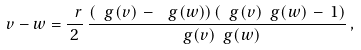<formula> <loc_0><loc_0><loc_500><loc_500>v - w = \frac { \ r } { 2 } \, \frac { ( \ g ( v ) \, - \, \ g ( w ) ) \, ( \ g ( v ) \ g ( w ) \, - \, 1 ) } { \ g ( v ) \ g ( w ) } \, ,</formula> 